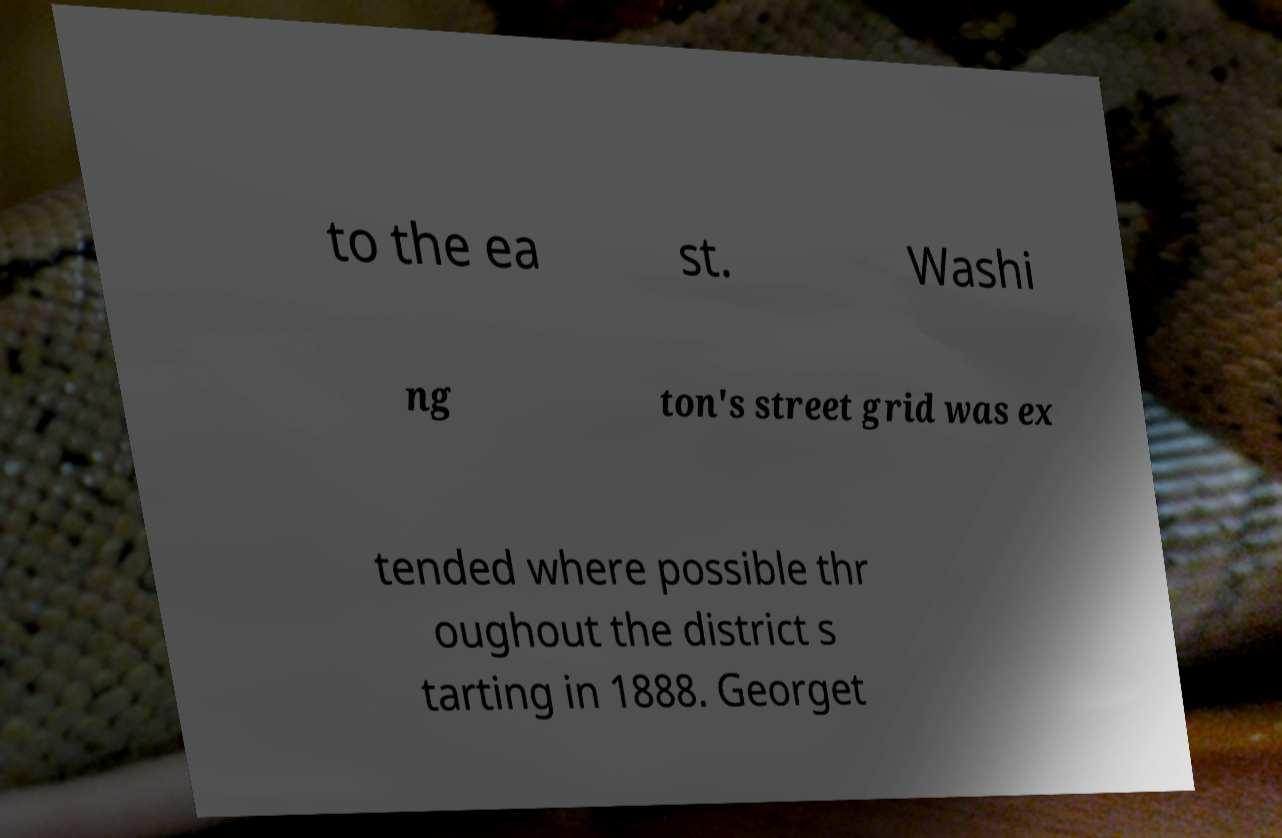For documentation purposes, I need the text within this image transcribed. Could you provide that? to the ea st. Washi ng ton's street grid was ex tended where possible thr oughout the district s tarting in 1888. Georget 